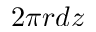Convert formula to latex. <formula><loc_0><loc_0><loc_500><loc_500>2 \pi r d z</formula> 